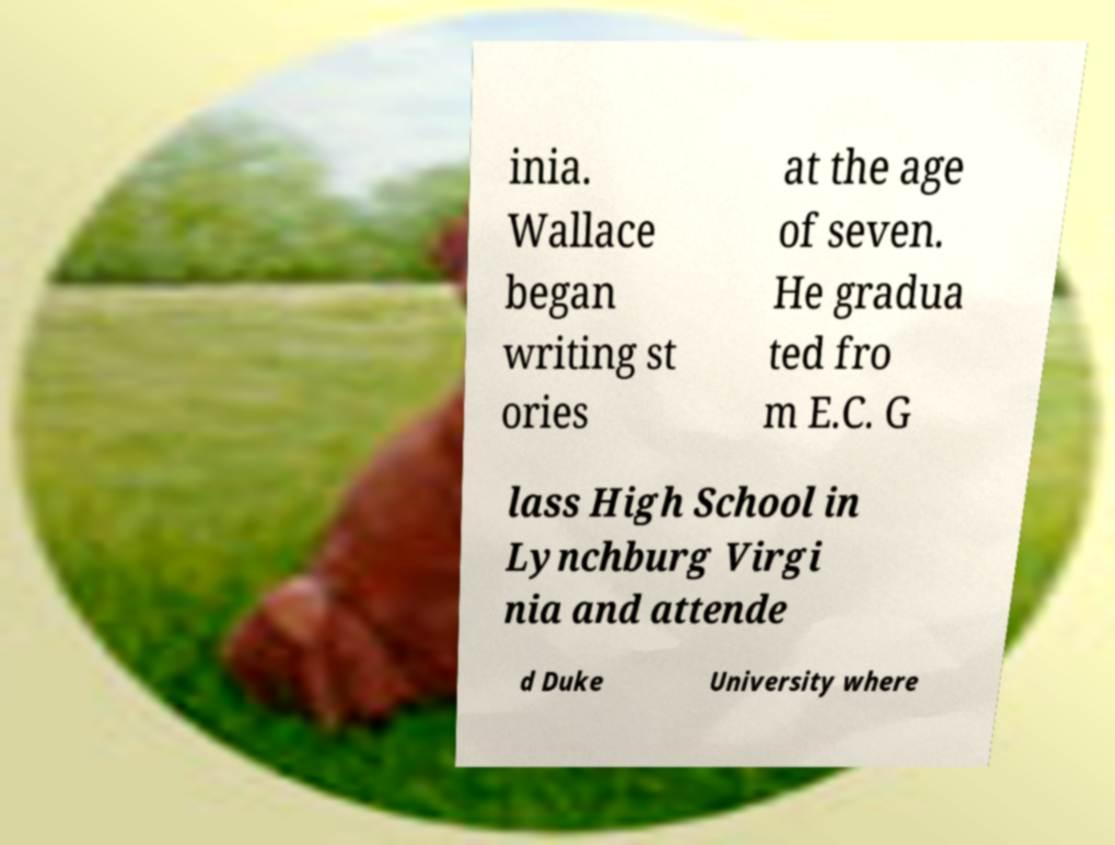Can you read and provide the text displayed in the image?This photo seems to have some interesting text. Can you extract and type it out for me? inia. Wallace began writing st ories at the age of seven. He gradua ted fro m E.C. G lass High School in Lynchburg Virgi nia and attende d Duke University where 